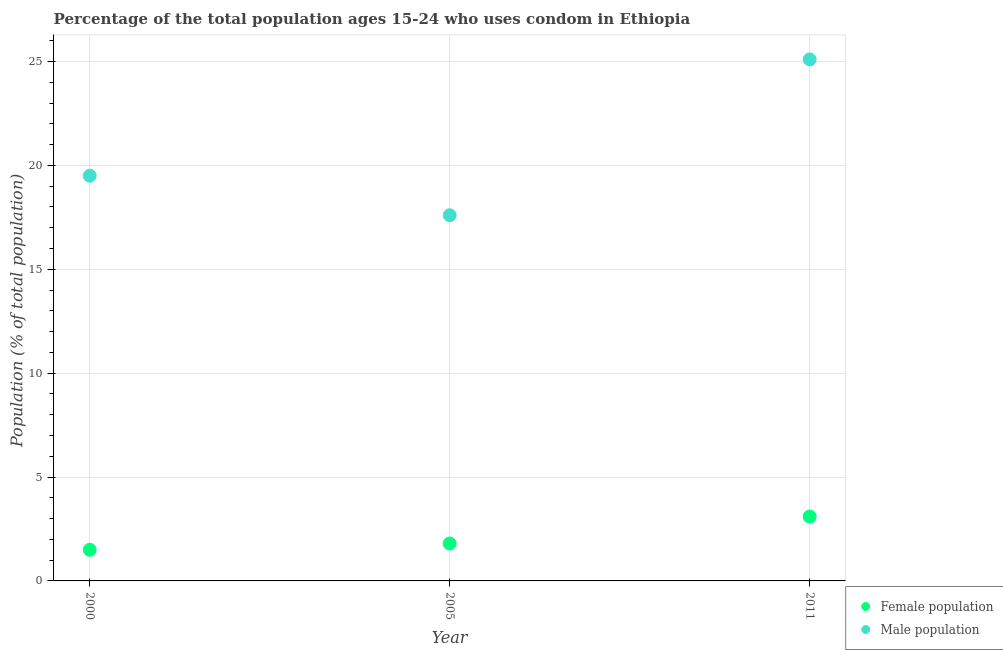Is the number of dotlines equal to the number of legend labels?
Offer a terse response. Yes. What is the male population in 2005?
Your answer should be compact. 17.6. Across all years, what is the maximum male population?
Keep it short and to the point. 25.1. In which year was the male population maximum?
Offer a terse response. 2011. What is the total male population in the graph?
Give a very brief answer. 62.2. What is the difference between the male population in 2000 and that in 2011?
Give a very brief answer. -5.6. What is the difference between the female population in 2011 and the male population in 2000?
Offer a very short reply. -16.4. What is the average male population per year?
Ensure brevity in your answer.  20.73. What is the ratio of the male population in 2000 to that in 2005?
Offer a very short reply. 1.11. Is the female population in 2005 less than that in 2011?
Provide a succinct answer. Yes. Is the difference between the male population in 2000 and 2005 greater than the difference between the female population in 2000 and 2005?
Your response must be concise. Yes. What is the difference between the highest and the second highest female population?
Ensure brevity in your answer.  1.3. What is the difference between the highest and the lowest female population?
Your answer should be compact. 1.6. In how many years, is the female population greater than the average female population taken over all years?
Your response must be concise. 1. Is the sum of the male population in 2000 and 2011 greater than the maximum female population across all years?
Provide a succinct answer. Yes. Is the male population strictly less than the female population over the years?
Make the answer very short. No. How many years are there in the graph?
Your response must be concise. 3. What is the difference between two consecutive major ticks on the Y-axis?
Offer a very short reply. 5. Does the graph contain grids?
Your response must be concise. Yes. How many legend labels are there?
Provide a succinct answer. 2. How are the legend labels stacked?
Ensure brevity in your answer.  Vertical. What is the title of the graph?
Make the answer very short. Percentage of the total population ages 15-24 who uses condom in Ethiopia. What is the label or title of the Y-axis?
Offer a terse response. Population (% of total population) . What is the Population (% of total population)  of Male population in 2000?
Provide a succinct answer. 19.5. What is the Population (% of total population)  of Female population in 2005?
Provide a succinct answer. 1.8. What is the Population (% of total population)  of Male population in 2005?
Provide a succinct answer. 17.6. What is the Population (% of total population)  of Male population in 2011?
Make the answer very short. 25.1. Across all years, what is the maximum Population (% of total population)  in Male population?
Provide a short and direct response. 25.1. What is the total Population (% of total population)  of Male population in the graph?
Keep it short and to the point. 62.2. What is the difference between the Population (% of total population)  of Female population in 2000 and that in 2005?
Your response must be concise. -0.3. What is the difference between the Population (% of total population)  in Male population in 2000 and that in 2005?
Your response must be concise. 1.9. What is the difference between the Population (% of total population)  in Female population in 2005 and that in 2011?
Make the answer very short. -1.3. What is the difference between the Population (% of total population)  of Male population in 2005 and that in 2011?
Your answer should be compact. -7.5. What is the difference between the Population (% of total population)  of Female population in 2000 and the Population (% of total population)  of Male population in 2005?
Give a very brief answer. -16.1. What is the difference between the Population (% of total population)  in Female population in 2000 and the Population (% of total population)  in Male population in 2011?
Your answer should be very brief. -23.6. What is the difference between the Population (% of total population)  in Female population in 2005 and the Population (% of total population)  in Male population in 2011?
Keep it short and to the point. -23.3. What is the average Population (% of total population)  of Female population per year?
Keep it short and to the point. 2.13. What is the average Population (% of total population)  of Male population per year?
Keep it short and to the point. 20.73. In the year 2005, what is the difference between the Population (% of total population)  in Female population and Population (% of total population)  in Male population?
Provide a succinct answer. -15.8. In the year 2011, what is the difference between the Population (% of total population)  of Female population and Population (% of total population)  of Male population?
Provide a succinct answer. -22. What is the ratio of the Population (% of total population)  in Male population in 2000 to that in 2005?
Provide a short and direct response. 1.11. What is the ratio of the Population (% of total population)  in Female population in 2000 to that in 2011?
Offer a very short reply. 0.48. What is the ratio of the Population (% of total population)  of Male population in 2000 to that in 2011?
Ensure brevity in your answer.  0.78. What is the ratio of the Population (% of total population)  in Female population in 2005 to that in 2011?
Provide a succinct answer. 0.58. What is the ratio of the Population (% of total population)  in Male population in 2005 to that in 2011?
Keep it short and to the point. 0.7. What is the difference between the highest and the lowest Population (% of total population)  in Female population?
Your response must be concise. 1.6. What is the difference between the highest and the lowest Population (% of total population)  in Male population?
Provide a succinct answer. 7.5. 